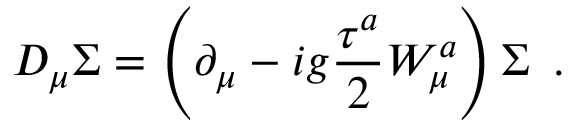Convert formula to latex. <formula><loc_0><loc_0><loc_500><loc_500>D _ { \mu } \Sigma = \left ( \partial _ { \mu } - i g \frac { \tau ^ { a } } { 2 } W _ { \mu } ^ { a } \right ) \Sigma \, .</formula> 